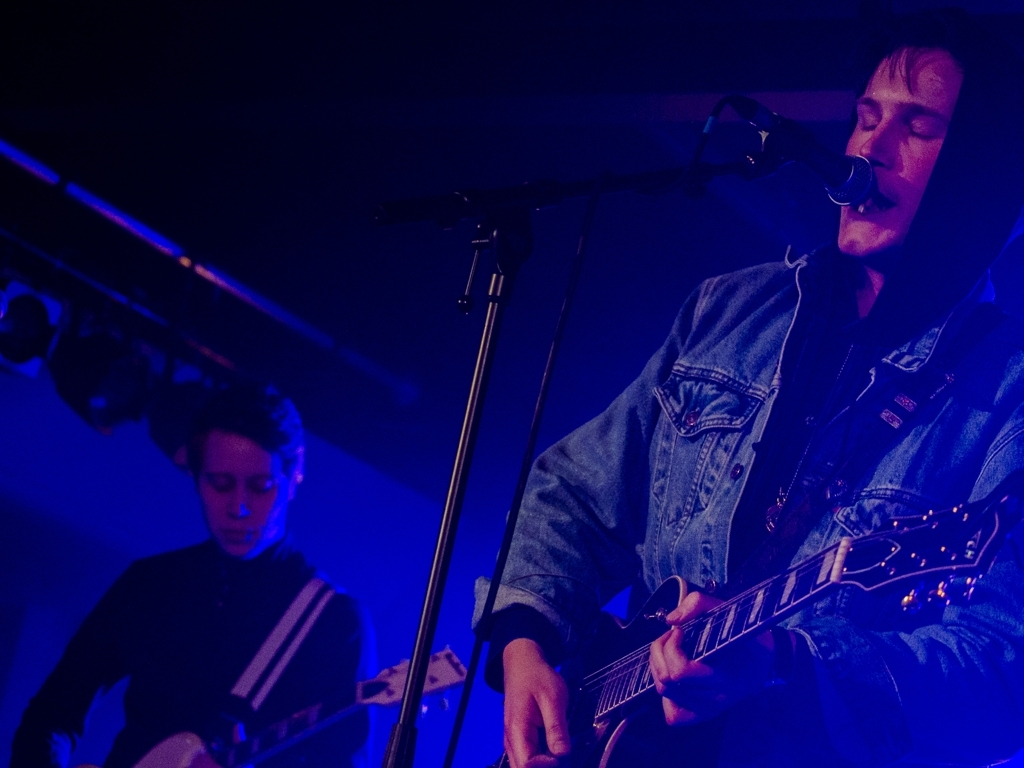How would this image change if it was taken during a daytime outdoor concert? In a daytime outdoor setting, the image would have a much brighter and natural light, possibly with strong shadows if it's sunny. The atmosphere would likely feel more casual and less intimate, and the musicians' expressions might be more relaxed or energetic, responding to a larger audience and an open-air environment. 